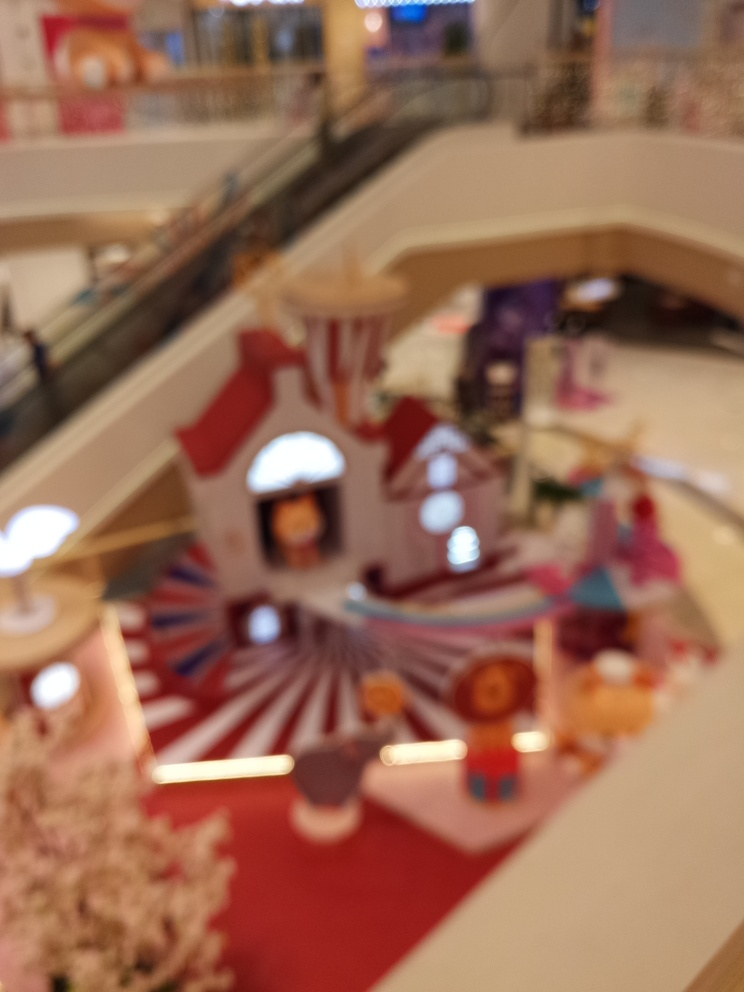What kind of mood or atmosphere do you think the creators of this space were intending to establish? The vibrant colors and the soft, diffused lighting that can be made out, even through the blur, suggest a welcoming and lively atmosphere. The intent might have been to create a space that feels dynamic and inviting, encouraging visitors to linger and enjoy their time within this setting. 